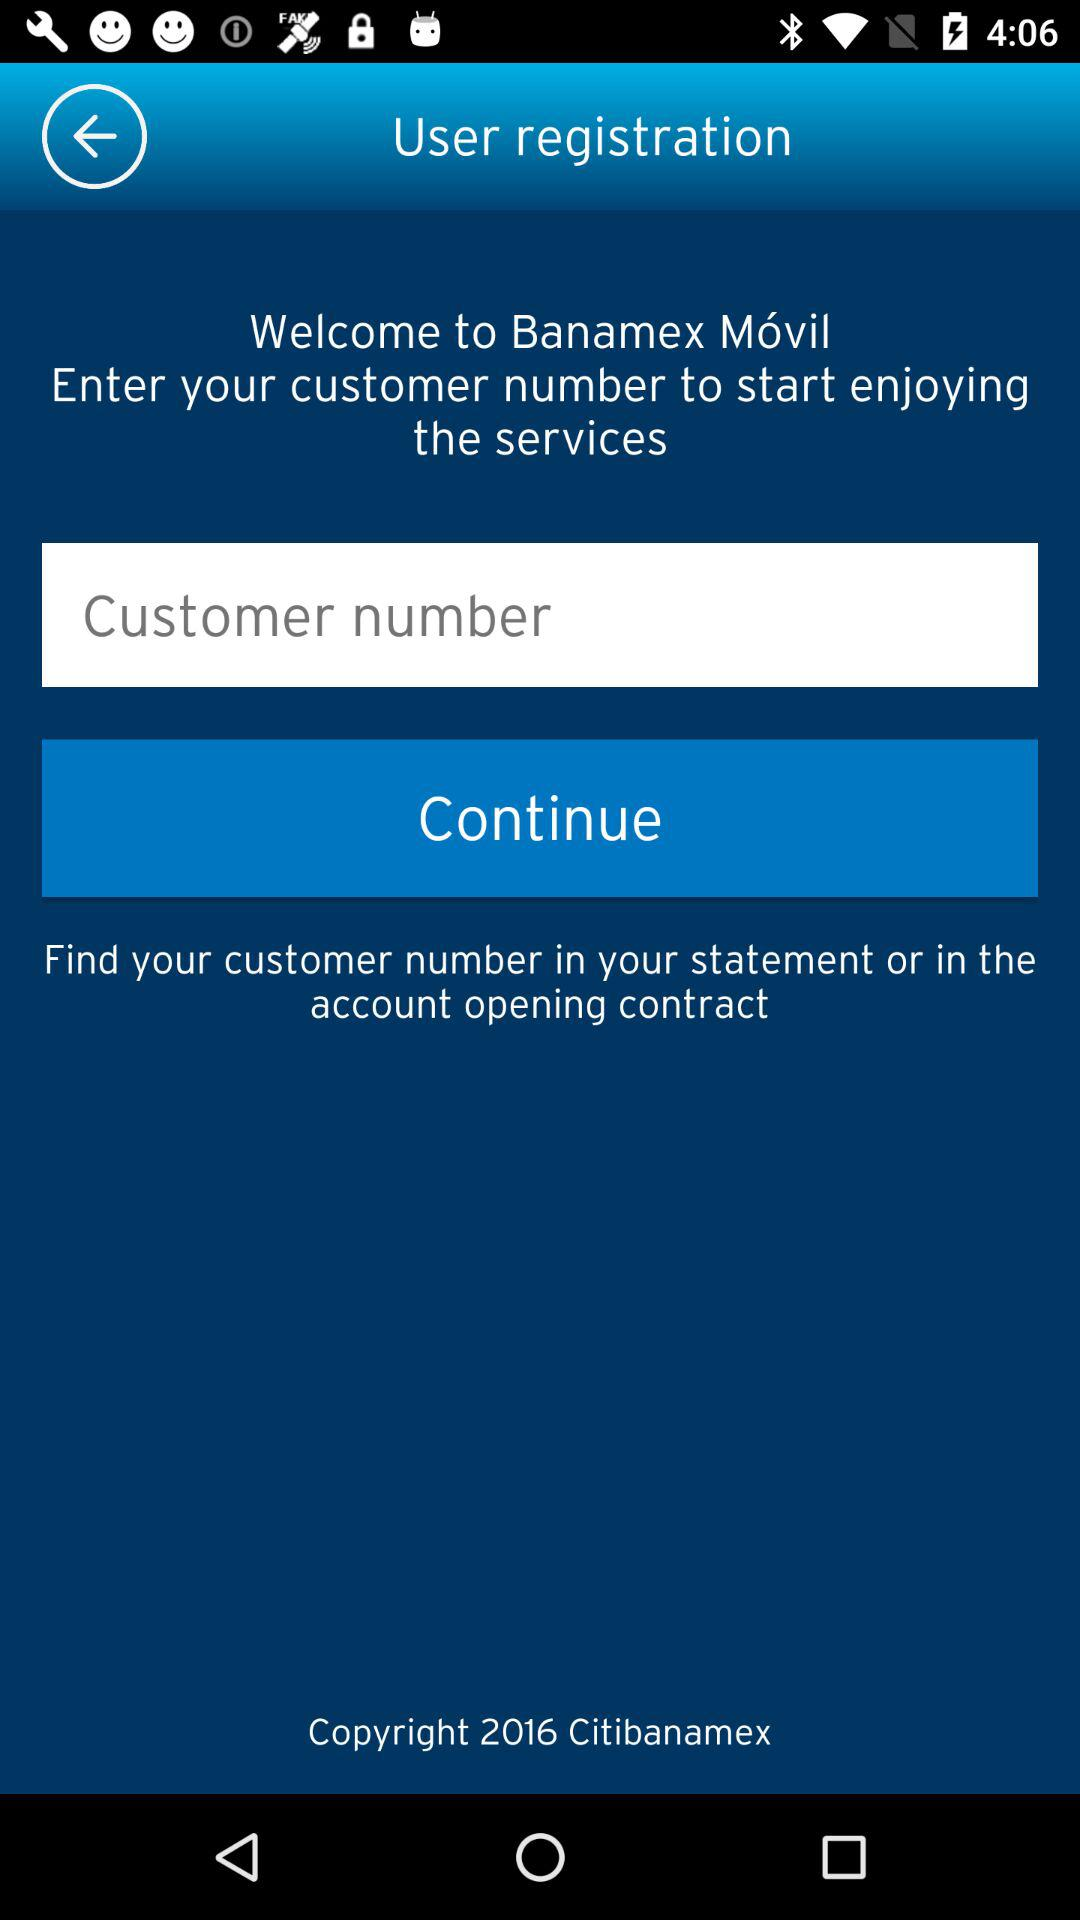Where can we find our customer number? You can find your customer number in your statement or in the account opening contract. 